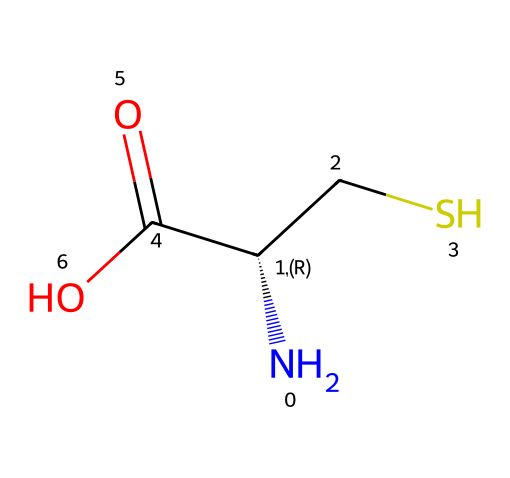What is the main functional group present in this compound? The compound features a carboxylic acid functional group, indicated by the -COOH part of the structure. This is identifiable by the presence of a carbon atom double bonded to an oxygen atom and single bonded to a hydroxyl group (-OH).
Answer: carboxylic acid How many distinct atoms are present in the compound? By analyzing the SMILES representation, we find 4 distinct atom types: nitrogen (N), carbon (C), sulfur (S), and oxygen (O). Each atom type is counted, making a total of 4 distinct types.
Answer: 4 What type of amino acid is represented by this structure? The given SMILES indicates this is a cysteine amino acid, identified by the presence of a thiol (-SH) group attached directly to the carbon chain, which is characteristic of cysteine.
Answer: cysteine What is the stereochemistry of the central carbon in the amino acid? The representation specifies a chiral carbon with a “C@@H” notation, indicating that the central carbon is chiral and has two distinct spatial arrangements or enantiomers (R and S configurations).
Answer: chiral How does the presence of sulfur influence protein folding? The sulfur atom in cysteine facilitates the formation of disulfide bonds through its thiol (-SH) groups, which can link different parts of a protein chain, thus affecting the overall tertiary structure of the protein.
Answer: disulfide bonds What is the oxidation state of the sulfur in this compound? The sulfur in cysteine is bonded to a carbon atom and a hydrogen atom, generally in a -I oxidation state in organic compounds, which indicates it is in a reduced form. This can be determined by analyzing the connections of sulfur to other atoms in the structure.
Answer: -I 